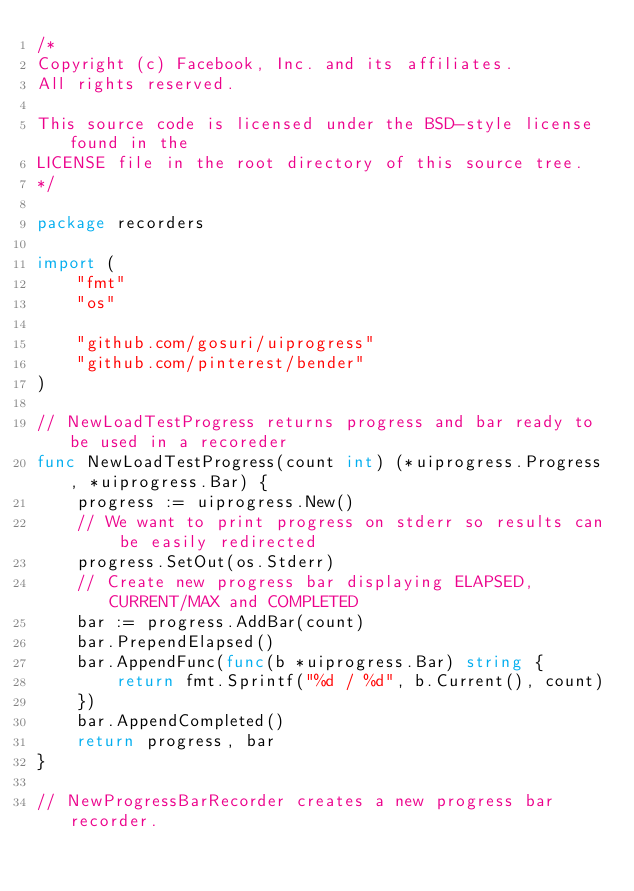Convert code to text. <code><loc_0><loc_0><loc_500><loc_500><_Go_>/*
Copyright (c) Facebook, Inc. and its affiliates.
All rights reserved.

This source code is licensed under the BSD-style license found in the
LICENSE file in the root directory of this source tree.
*/

package recorders

import (
	"fmt"
	"os"

	"github.com/gosuri/uiprogress"
	"github.com/pinterest/bender"
)

// NewLoadTestProgress returns progress and bar ready to be used in a recoreder
func NewLoadTestProgress(count int) (*uiprogress.Progress, *uiprogress.Bar) {
	progress := uiprogress.New()
	// We want to print progress on stderr so results can be easily redirected
	progress.SetOut(os.Stderr)
	// Create new progress bar displaying ELAPSED, CURRENT/MAX and COMPLETED
	bar := progress.AddBar(count)
	bar.PrependElapsed()
	bar.AppendFunc(func(b *uiprogress.Bar) string {
		return fmt.Sprintf("%d / %d", b.Current(), count)
	})
	bar.AppendCompleted()
	return progress, bar
}

// NewProgressBarRecorder creates a new progress bar recorder.</code> 